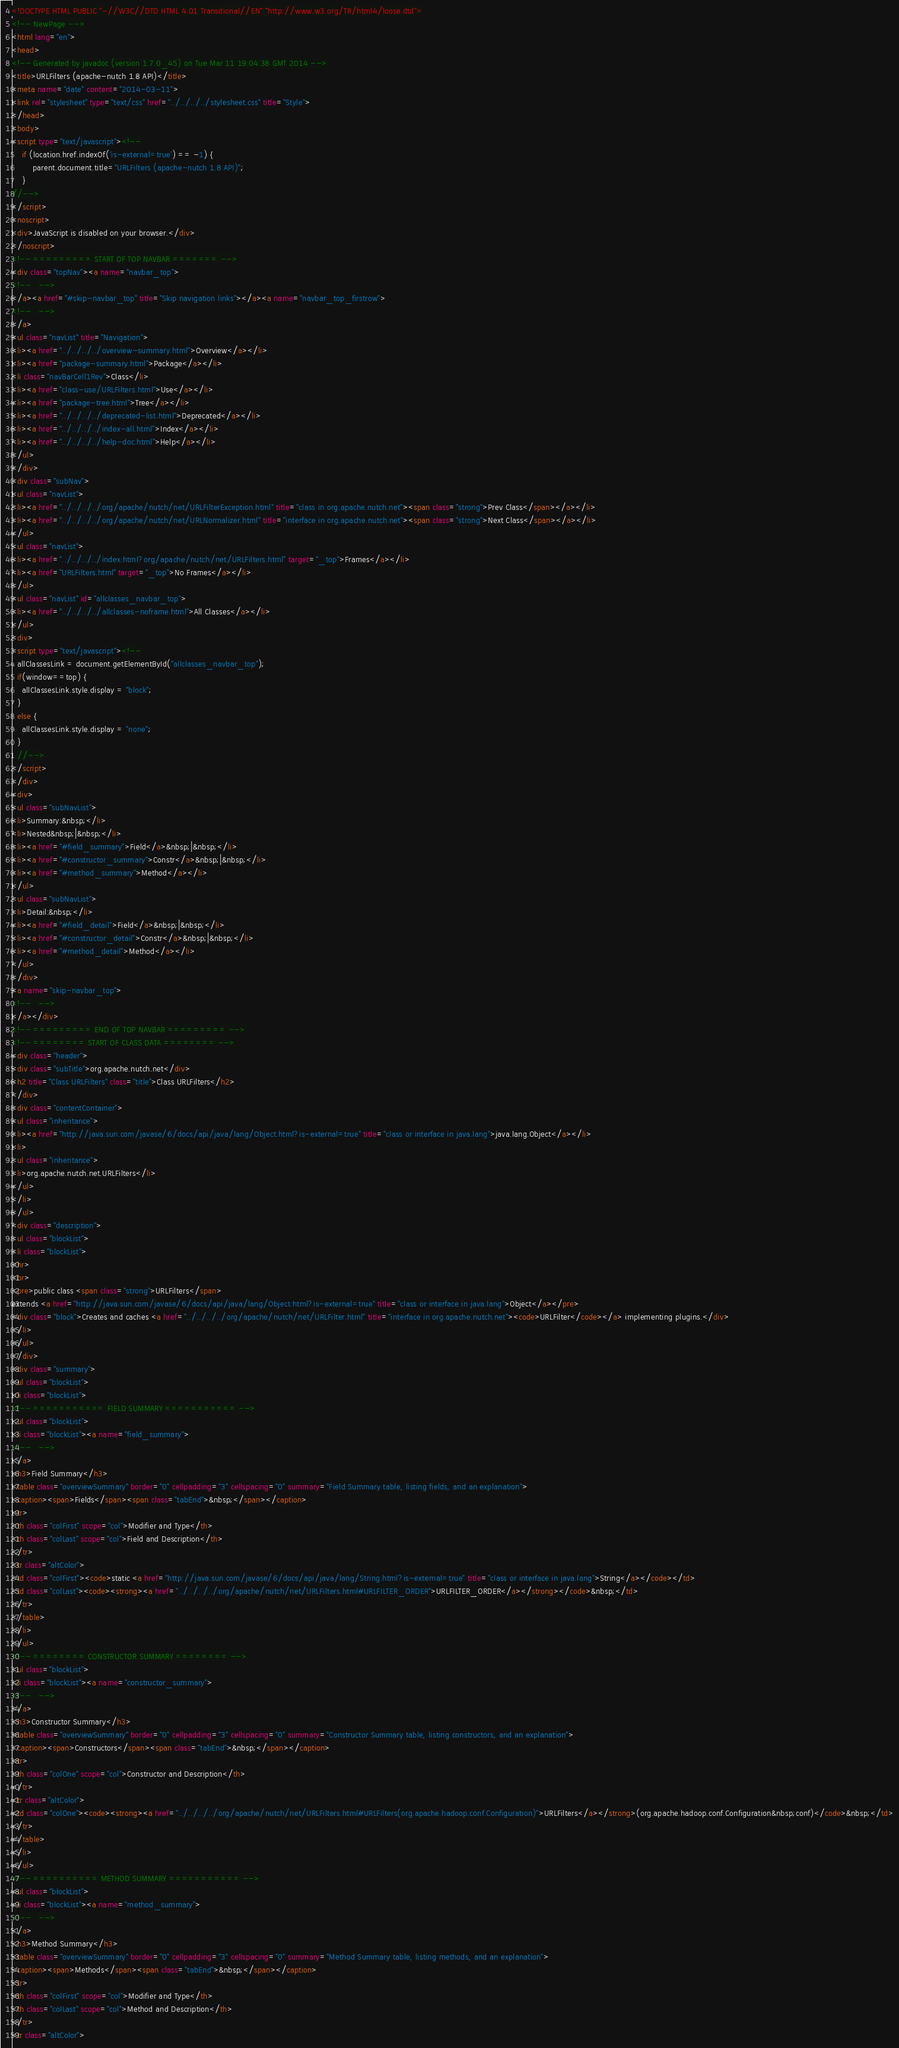<code> <loc_0><loc_0><loc_500><loc_500><_HTML_><!DOCTYPE HTML PUBLIC "-//W3C//DTD HTML 4.01 Transitional//EN" "http://www.w3.org/TR/html4/loose.dtd">
<!-- NewPage -->
<html lang="en">
<head>
<!-- Generated by javadoc (version 1.7.0_45) on Tue Mar 11 19:04:38 GMT 2014 -->
<title>URLFilters (apache-nutch 1.8 API)</title>
<meta name="date" content="2014-03-11">
<link rel="stylesheet" type="text/css" href="../../../../stylesheet.css" title="Style">
</head>
<body>
<script type="text/javascript"><!--
    if (location.href.indexOf('is-external=true') == -1) {
        parent.document.title="URLFilters (apache-nutch 1.8 API)";
    }
//-->
</script>
<noscript>
<div>JavaScript is disabled on your browser.</div>
</noscript>
<!-- ========= START OF TOP NAVBAR ======= -->
<div class="topNav"><a name="navbar_top">
<!--   -->
</a><a href="#skip-navbar_top" title="Skip navigation links"></a><a name="navbar_top_firstrow">
<!--   -->
</a>
<ul class="navList" title="Navigation">
<li><a href="../../../../overview-summary.html">Overview</a></li>
<li><a href="package-summary.html">Package</a></li>
<li class="navBarCell1Rev">Class</li>
<li><a href="class-use/URLFilters.html">Use</a></li>
<li><a href="package-tree.html">Tree</a></li>
<li><a href="../../../../deprecated-list.html">Deprecated</a></li>
<li><a href="../../../../index-all.html">Index</a></li>
<li><a href="../../../../help-doc.html">Help</a></li>
</ul>
</div>
<div class="subNav">
<ul class="navList">
<li><a href="../../../../org/apache/nutch/net/URLFilterException.html" title="class in org.apache.nutch.net"><span class="strong">Prev Class</span></a></li>
<li><a href="../../../../org/apache/nutch/net/URLNormalizer.html" title="interface in org.apache.nutch.net"><span class="strong">Next Class</span></a></li>
</ul>
<ul class="navList">
<li><a href="../../../../index.html?org/apache/nutch/net/URLFilters.html" target="_top">Frames</a></li>
<li><a href="URLFilters.html" target="_top">No Frames</a></li>
</ul>
<ul class="navList" id="allclasses_navbar_top">
<li><a href="../../../../allclasses-noframe.html">All Classes</a></li>
</ul>
<div>
<script type="text/javascript"><!--
  allClassesLink = document.getElementById("allclasses_navbar_top");
  if(window==top) {
    allClassesLink.style.display = "block";
  }
  else {
    allClassesLink.style.display = "none";
  }
  //-->
</script>
</div>
<div>
<ul class="subNavList">
<li>Summary:&nbsp;</li>
<li>Nested&nbsp;|&nbsp;</li>
<li><a href="#field_summary">Field</a>&nbsp;|&nbsp;</li>
<li><a href="#constructor_summary">Constr</a>&nbsp;|&nbsp;</li>
<li><a href="#method_summary">Method</a></li>
</ul>
<ul class="subNavList">
<li>Detail:&nbsp;</li>
<li><a href="#field_detail">Field</a>&nbsp;|&nbsp;</li>
<li><a href="#constructor_detail">Constr</a>&nbsp;|&nbsp;</li>
<li><a href="#method_detail">Method</a></li>
</ul>
</div>
<a name="skip-navbar_top">
<!--   -->
</a></div>
<!-- ========= END OF TOP NAVBAR ========= -->
<!-- ======== START OF CLASS DATA ======== -->
<div class="header">
<div class="subTitle">org.apache.nutch.net</div>
<h2 title="Class URLFilters" class="title">Class URLFilters</h2>
</div>
<div class="contentContainer">
<ul class="inheritance">
<li><a href="http://java.sun.com/javase/6/docs/api/java/lang/Object.html?is-external=true" title="class or interface in java.lang">java.lang.Object</a></li>
<li>
<ul class="inheritance">
<li>org.apache.nutch.net.URLFilters</li>
</ul>
</li>
</ul>
<div class="description">
<ul class="blockList">
<li class="blockList">
<hr>
<br>
<pre>public class <span class="strong">URLFilters</span>
extends <a href="http://java.sun.com/javase/6/docs/api/java/lang/Object.html?is-external=true" title="class or interface in java.lang">Object</a></pre>
<div class="block">Creates and caches <a href="../../../../org/apache/nutch/net/URLFilter.html" title="interface in org.apache.nutch.net"><code>URLFilter</code></a> implementing plugins.</div>
</li>
</ul>
</div>
<div class="summary">
<ul class="blockList">
<li class="blockList">
<!-- =========== FIELD SUMMARY =========== -->
<ul class="blockList">
<li class="blockList"><a name="field_summary">
<!--   -->
</a>
<h3>Field Summary</h3>
<table class="overviewSummary" border="0" cellpadding="3" cellspacing="0" summary="Field Summary table, listing fields, and an explanation">
<caption><span>Fields</span><span class="tabEnd">&nbsp;</span></caption>
<tr>
<th class="colFirst" scope="col">Modifier and Type</th>
<th class="colLast" scope="col">Field and Description</th>
</tr>
<tr class="altColor">
<td class="colFirst"><code>static <a href="http://java.sun.com/javase/6/docs/api/java/lang/String.html?is-external=true" title="class or interface in java.lang">String</a></code></td>
<td class="colLast"><code><strong><a href="../../../../org/apache/nutch/net/URLFilters.html#URLFILTER_ORDER">URLFILTER_ORDER</a></strong></code>&nbsp;</td>
</tr>
</table>
</li>
</ul>
<!-- ======== CONSTRUCTOR SUMMARY ======== -->
<ul class="blockList">
<li class="blockList"><a name="constructor_summary">
<!--   -->
</a>
<h3>Constructor Summary</h3>
<table class="overviewSummary" border="0" cellpadding="3" cellspacing="0" summary="Constructor Summary table, listing constructors, and an explanation">
<caption><span>Constructors</span><span class="tabEnd">&nbsp;</span></caption>
<tr>
<th class="colOne" scope="col">Constructor and Description</th>
</tr>
<tr class="altColor">
<td class="colOne"><code><strong><a href="../../../../org/apache/nutch/net/URLFilters.html#URLFilters(org.apache.hadoop.conf.Configuration)">URLFilters</a></strong>(org.apache.hadoop.conf.Configuration&nbsp;conf)</code>&nbsp;</td>
</tr>
</table>
</li>
</ul>
<!-- ========== METHOD SUMMARY =========== -->
<ul class="blockList">
<li class="blockList"><a name="method_summary">
<!--   -->
</a>
<h3>Method Summary</h3>
<table class="overviewSummary" border="0" cellpadding="3" cellspacing="0" summary="Method Summary table, listing methods, and an explanation">
<caption><span>Methods</span><span class="tabEnd">&nbsp;</span></caption>
<tr>
<th class="colFirst" scope="col">Modifier and Type</th>
<th class="colLast" scope="col">Method and Description</th>
</tr>
<tr class="altColor"></code> 